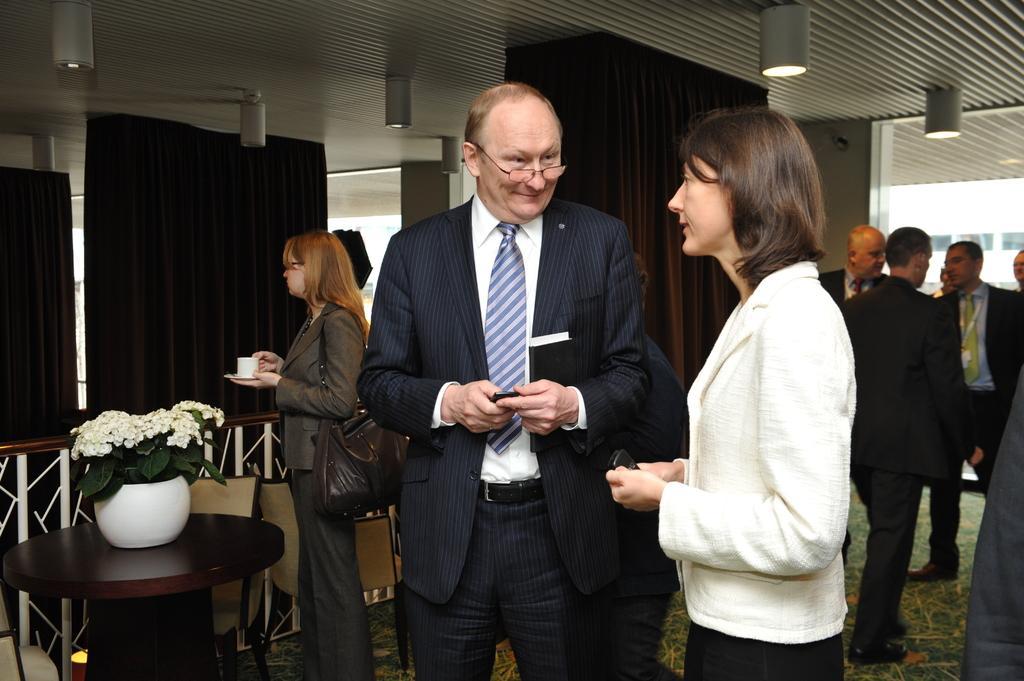Could you give a brief overview of what you see in this image? In this picture we can see some group of people are in the room, side we can see pot which is placed on the table, behind we can see cloth. 